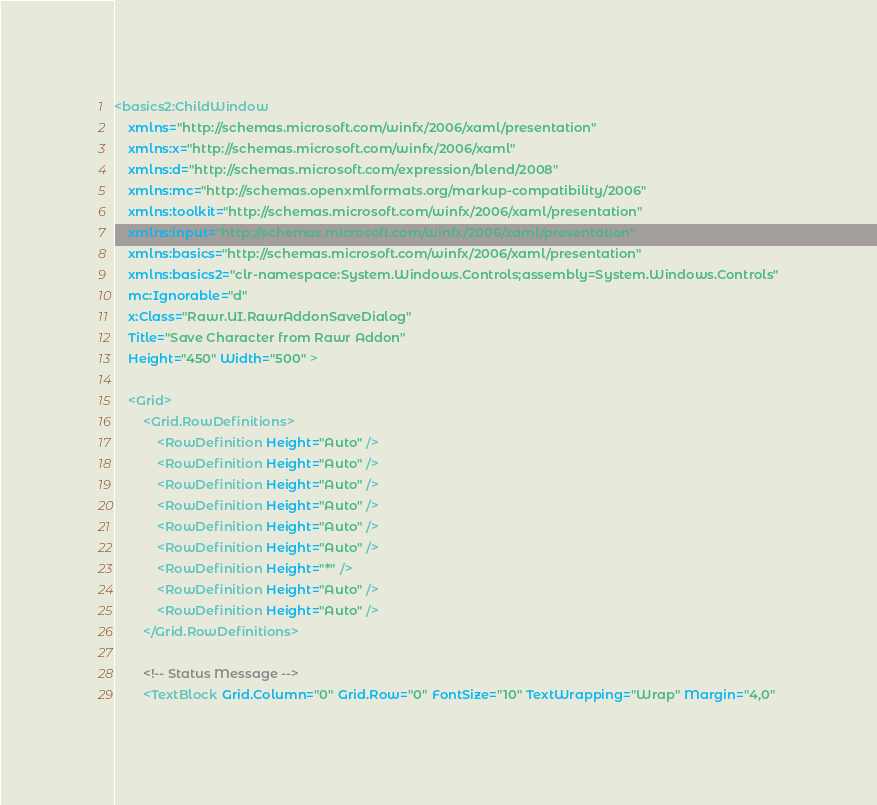Convert code to text. <code><loc_0><loc_0><loc_500><loc_500><_XML_><basics2:ChildWindow
    xmlns="http://schemas.microsoft.com/winfx/2006/xaml/presentation"
    xmlns:x="http://schemas.microsoft.com/winfx/2006/xaml"
    xmlns:d="http://schemas.microsoft.com/expression/blend/2008"
    xmlns:mc="http://schemas.openxmlformats.org/markup-compatibility/2006"
    xmlns:toolkit="http://schemas.microsoft.com/winfx/2006/xaml/presentation"
    xmlns:input="http://schemas.microsoft.com/winfx/2006/xaml/presentation"
    xmlns:basics="http://schemas.microsoft.com/winfx/2006/xaml/presentation"
    xmlns:basics2="clr-namespace:System.Windows.Controls;assembly=System.Windows.Controls"
    mc:Ignorable="d"
    x:Class="Rawr.UI.RawrAddonSaveDialog"
    Title="Save Character from Rawr Addon"
    Height="450" Width="500" >

    <Grid>
        <Grid.RowDefinitions>
            <RowDefinition Height="Auto" />
            <RowDefinition Height="Auto" />
            <RowDefinition Height="Auto" />
            <RowDefinition Height="Auto" />
            <RowDefinition Height="Auto" />
            <RowDefinition Height="Auto" />
            <RowDefinition Height="*" />
            <RowDefinition Height="Auto" />
            <RowDefinition Height="Auto" />
        </Grid.RowDefinitions>

        <!-- Status Message -->
        <TextBlock Grid.Column="0" Grid.Row="0" FontSize="10" TextWrapping="Wrap" Margin="4,0"</code> 